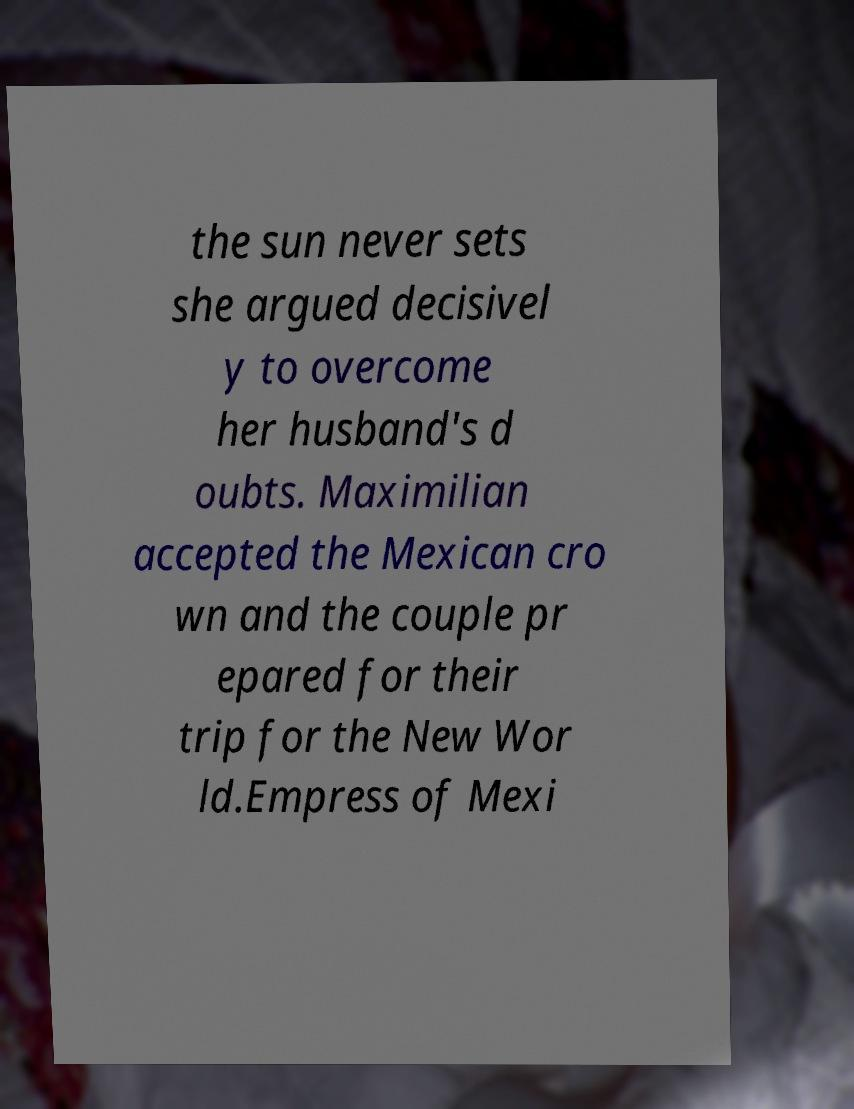There's text embedded in this image that I need extracted. Can you transcribe it verbatim? the sun never sets she argued decisivel y to overcome her husband's d oubts. Maximilian accepted the Mexican cro wn and the couple pr epared for their trip for the New Wor ld.Empress of Mexi 